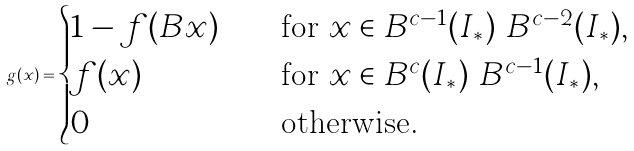Convert formula to latex. <formula><loc_0><loc_0><loc_500><loc_500>g ( x ) = \begin{cases} 1 - f ( B x ) \quad & \text {for } x \in B ^ { c - 1 } ( I _ { \ast } ) \ B ^ { c - 2 } ( I _ { \ast } ) , \\ f ( x ) \quad & \text {for } x \in B ^ { c } ( I _ { \ast } ) \ B ^ { c - 1 } ( I _ { \ast } ) , \\ 0 \quad & \text {otherwise.} \end{cases}</formula> 